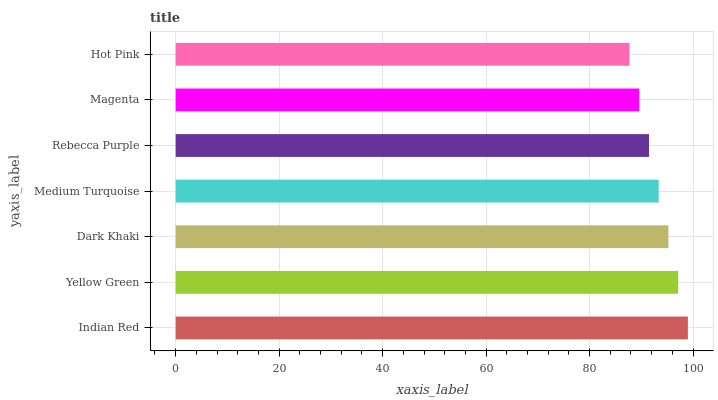Is Hot Pink the minimum?
Answer yes or no. Yes. Is Indian Red the maximum?
Answer yes or no. Yes. Is Yellow Green the minimum?
Answer yes or no. No. Is Yellow Green the maximum?
Answer yes or no. No. Is Indian Red greater than Yellow Green?
Answer yes or no. Yes. Is Yellow Green less than Indian Red?
Answer yes or no. Yes. Is Yellow Green greater than Indian Red?
Answer yes or no. No. Is Indian Red less than Yellow Green?
Answer yes or no. No. Is Medium Turquoise the high median?
Answer yes or no. Yes. Is Medium Turquoise the low median?
Answer yes or no. Yes. Is Dark Khaki the high median?
Answer yes or no. No. Is Yellow Green the low median?
Answer yes or no. No. 